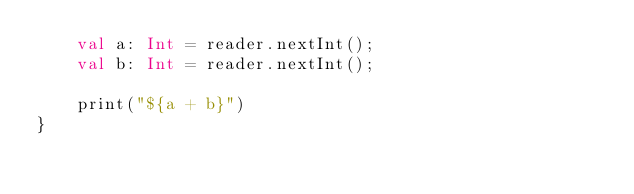<code> <loc_0><loc_0><loc_500><loc_500><_Kotlin_>    val a: Int = reader.nextInt();
    val b: Int = reader.nextInt();

    print("${a + b}")
}</code> 